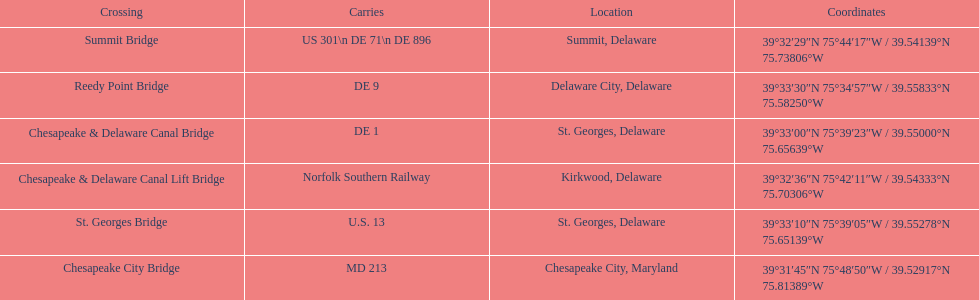Give me the full table as a dictionary. {'header': ['Crossing', 'Carries', 'Location', 'Coordinates'], 'rows': [['Summit Bridge', 'US 301\\n DE 71\\n DE 896', 'Summit, Delaware', '39°32′29″N 75°44′17″W\ufeff / \ufeff39.54139°N 75.73806°W'], ['Reedy Point Bridge', 'DE\xa09', 'Delaware City, Delaware', '39°33′30″N 75°34′57″W\ufeff / \ufeff39.55833°N 75.58250°W'], ['Chesapeake & Delaware Canal Bridge', 'DE 1', 'St.\xa0Georges, Delaware', '39°33′00″N 75°39′23″W\ufeff / \ufeff39.55000°N 75.65639°W'], ['Chesapeake & Delaware Canal Lift Bridge', 'Norfolk Southern Railway', 'Kirkwood, Delaware', '39°32′36″N 75°42′11″W\ufeff / \ufeff39.54333°N 75.70306°W'], ['St.\xa0Georges Bridge', 'U.S.\xa013', 'St.\xa0Georges, Delaware', '39°33′10″N 75°39′05″W\ufeff / \ufeff39.55278°N 75.65139°W'], ['Chesapeake City Bridge', 'MD 213', 'Chesapeake City, Maryland', '39°31′45″N 75°48′50″W\ufeff / \ufeff39.52917°N 75.81389°W']]} How many crossings are in maryland? 1. 